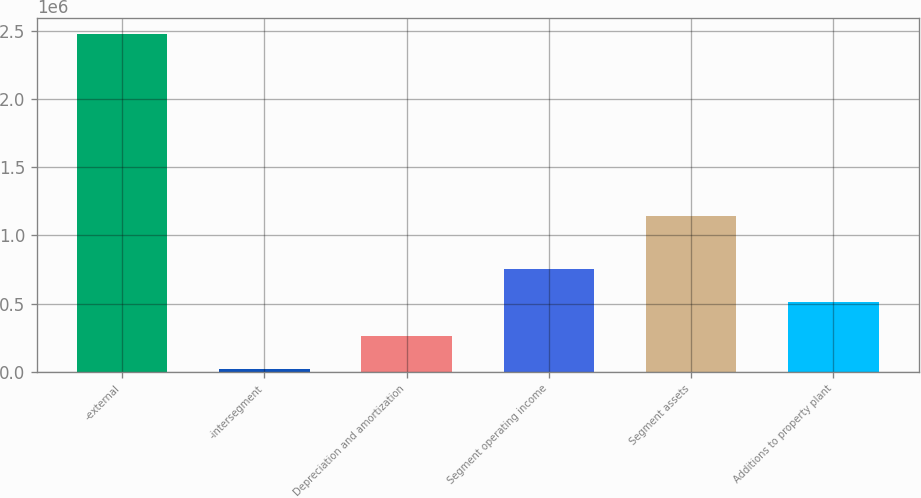Convert chart to OTSL. <chart><loc_0><loc_0><loc_500><loc_500><bar_chart><fcel>-external<fcel>-intersegment<fcel>Depreciation and amortization<fcel>Segment operating income<fcel>Segment assets<fcel>Additions to property plant<nl><fcel>2.47143e+06<fcel>20767<fcel>265833<fcel>755966<fcel>1.13987e+06<fcel>510900<nl></chart> 